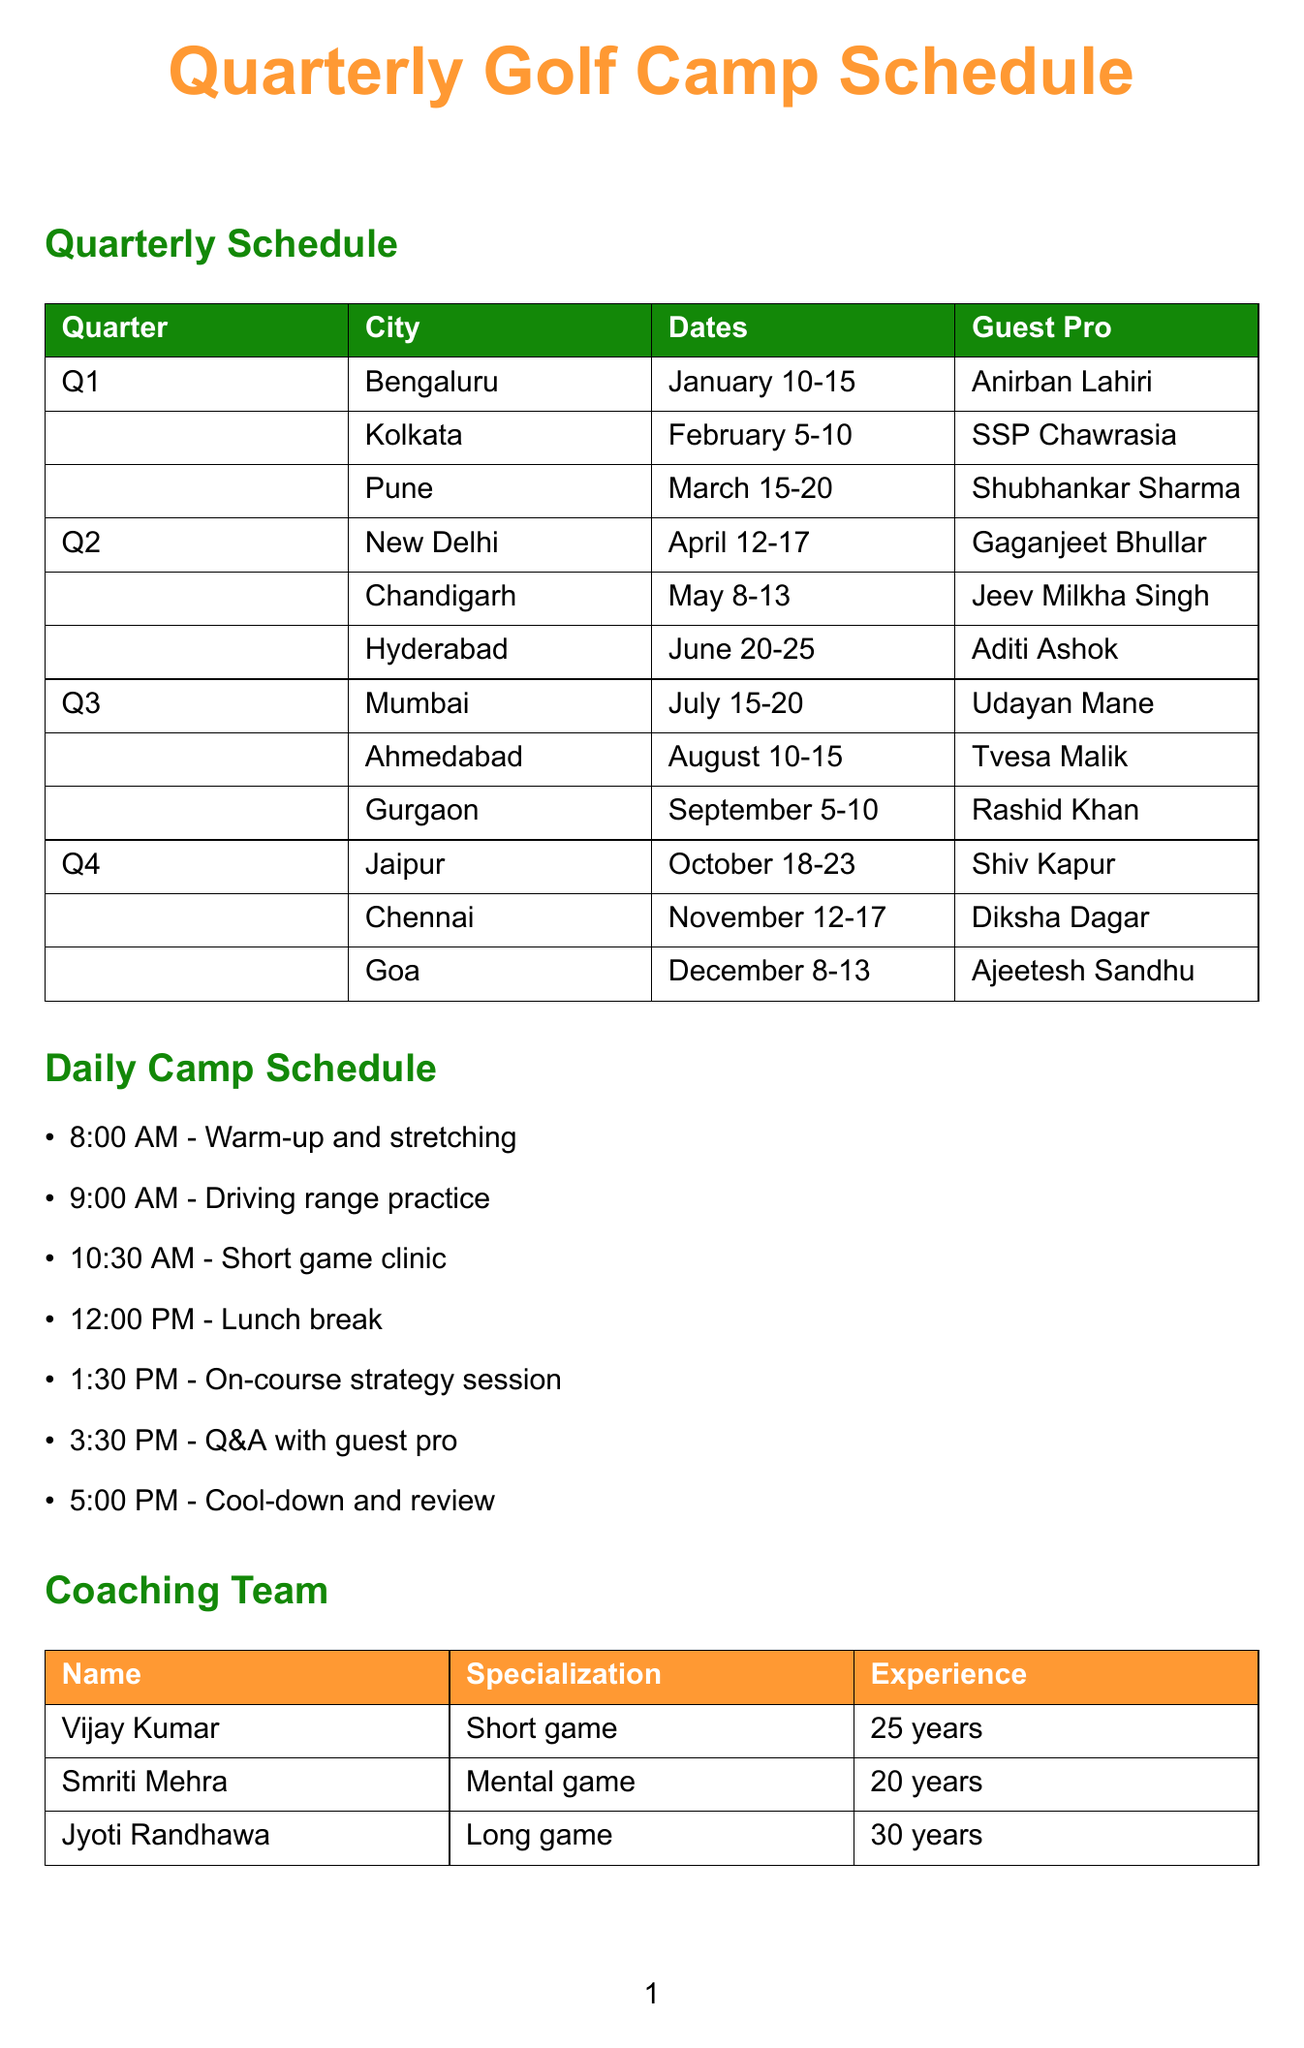What are the dates for the camp in Bengaluru? The dates for the camp in Bengaluru are mentioned in the document under the Q1 schedule.
Answer: January 10-15 Who is the guest pro in Pune? The guest professional for the camp in Pune is listed under the Q1 schedule.
Answer: Shubhankar Sharma How many years of experience does Vijay Kumar have? The document provides the experience details for each coach, which includes Vijay Kumar's years of experience.
Answer: 25 years In which quarter will the Junior Golf Challenge happen? The document states that the Junior Golf Challenge is a special event that occurs once per quarter, implying it happens in all quarters.
Answer: All quarters What city hosts the camp in Q3? The document lists multiple locations for Q3 camps, allowing us to identify the cities.
Answer: Mumbai, Ahmedabad, Gurgaon Which hotel chain is a partner in Chennai? Accommodation partners are listed with their associated locations, which can help in identifying partners for specific cities like Chennai.
Answer: ITC Hotels What is the location for the camp with Aditi Ashok? The document specifies the locations of each camp, allowing us to find the correct city for Aditi Ashok's camp.
Answer: Hyderabad How many guest professionals appear during the Q2 camps? The Q2 schedule lists three camps with different guest professionals, allowing us to count them.
Answer: 3 